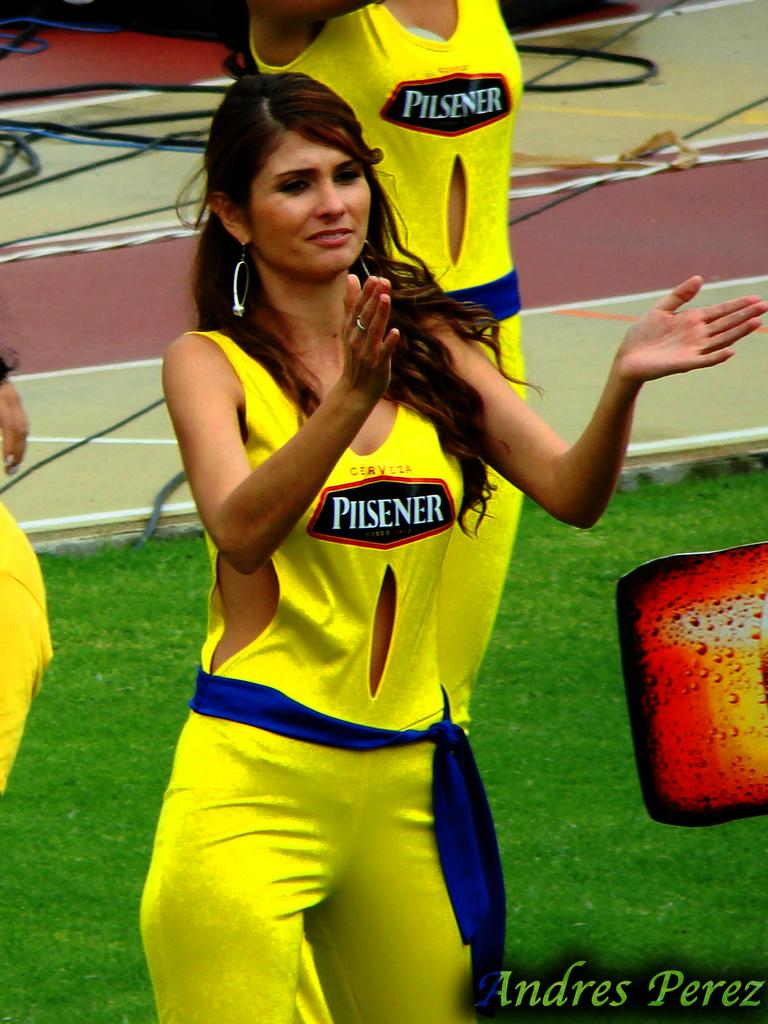<image>
Describe the image concisely. Cheerleaders wearing yellow with the logo Pilsener support the team from the sidelines. 